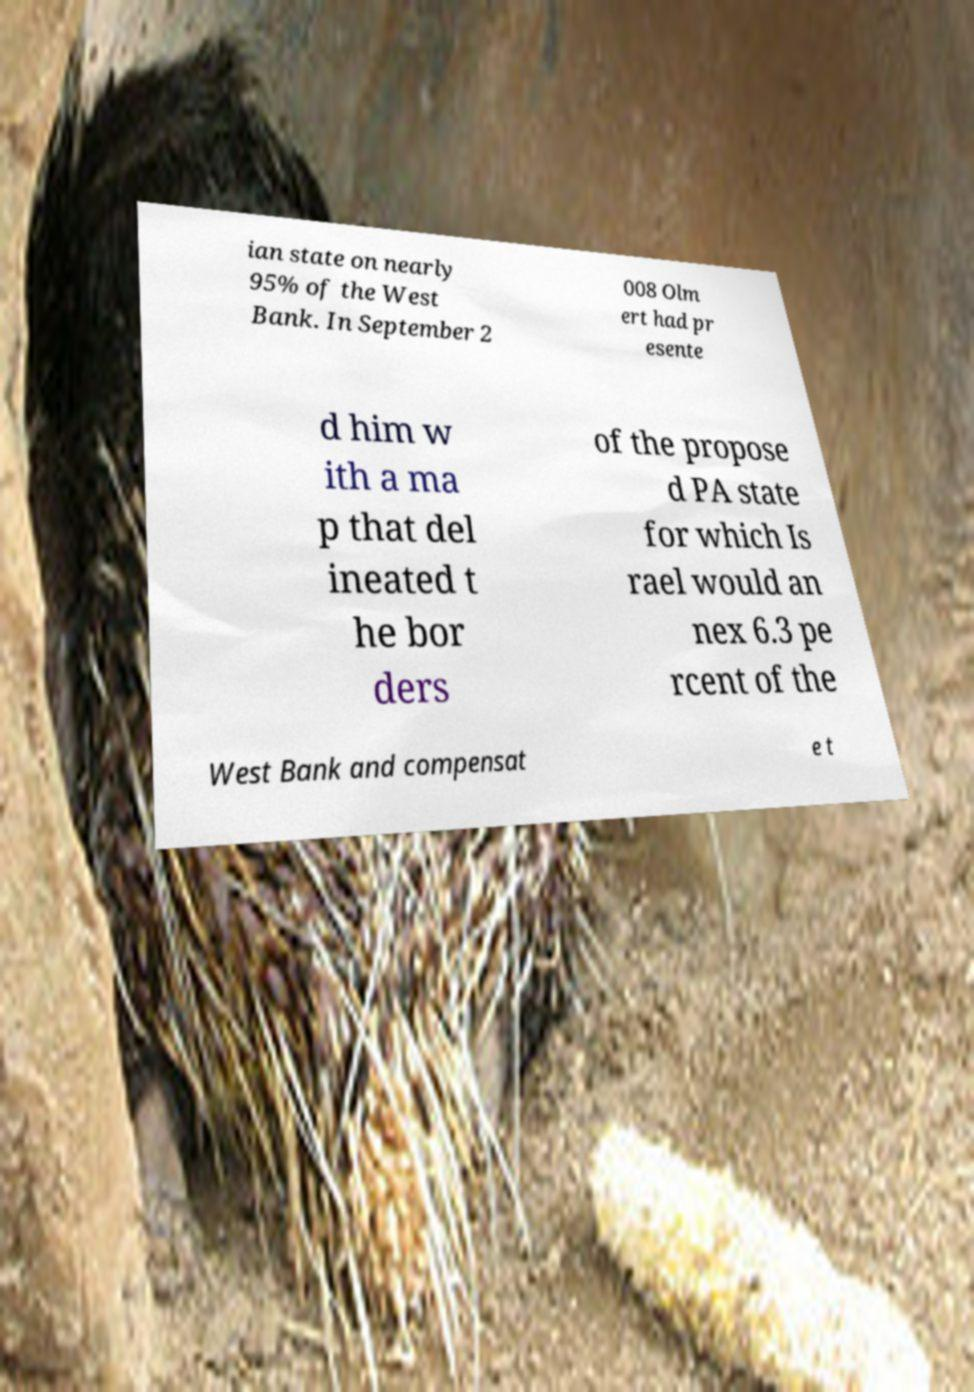There's text embedded in this image that I need extracted. Can you transcribe it verbatim? ian state on nearly 95% of the West Bank. In September 2 008 Olm ert had pr esente d him w ith a ma p that del ineated t he bor ders of the propose d PA state for which Is rael would an nex 6.3 pe rcent of the West Bank and compensat e t 